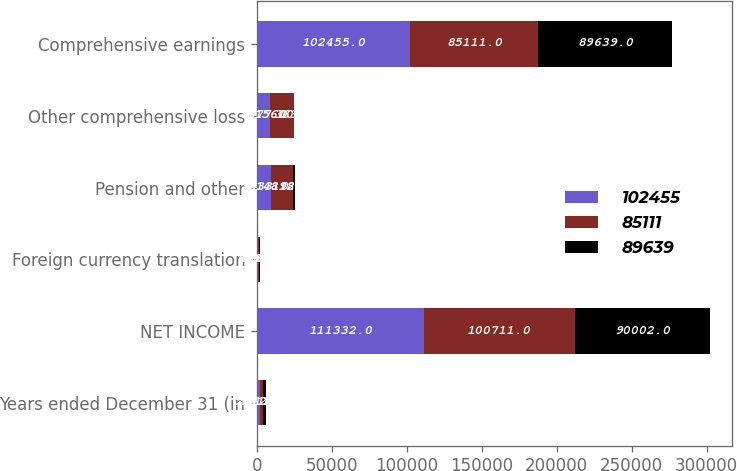<chart> <loc_0><loc_0><loc_500><loc_500><stacked_bar_chart><ecel><fcel>Years ended December 31 (in<fcel>NET INCOME<fcel>Foreign currency translation<fcel>Pension and other<fcel>Other comprehensive loss<fcel>Comprehensive earnings<nl><fcel>102455<fcel>2012<fcel>111332<fcel>656<fcel>9533<fcel>8877<fcel>102455<nl><fcel>85111<fcel>2011<fcel>100711<fcel>708<fcel>14892<fcel>15600<fcel>85111<nl><fcel>89639<fcel>2010<fcel>90002<fcel>826<fcel>1189<fcel>363<fcel>89639<nl></chart> 